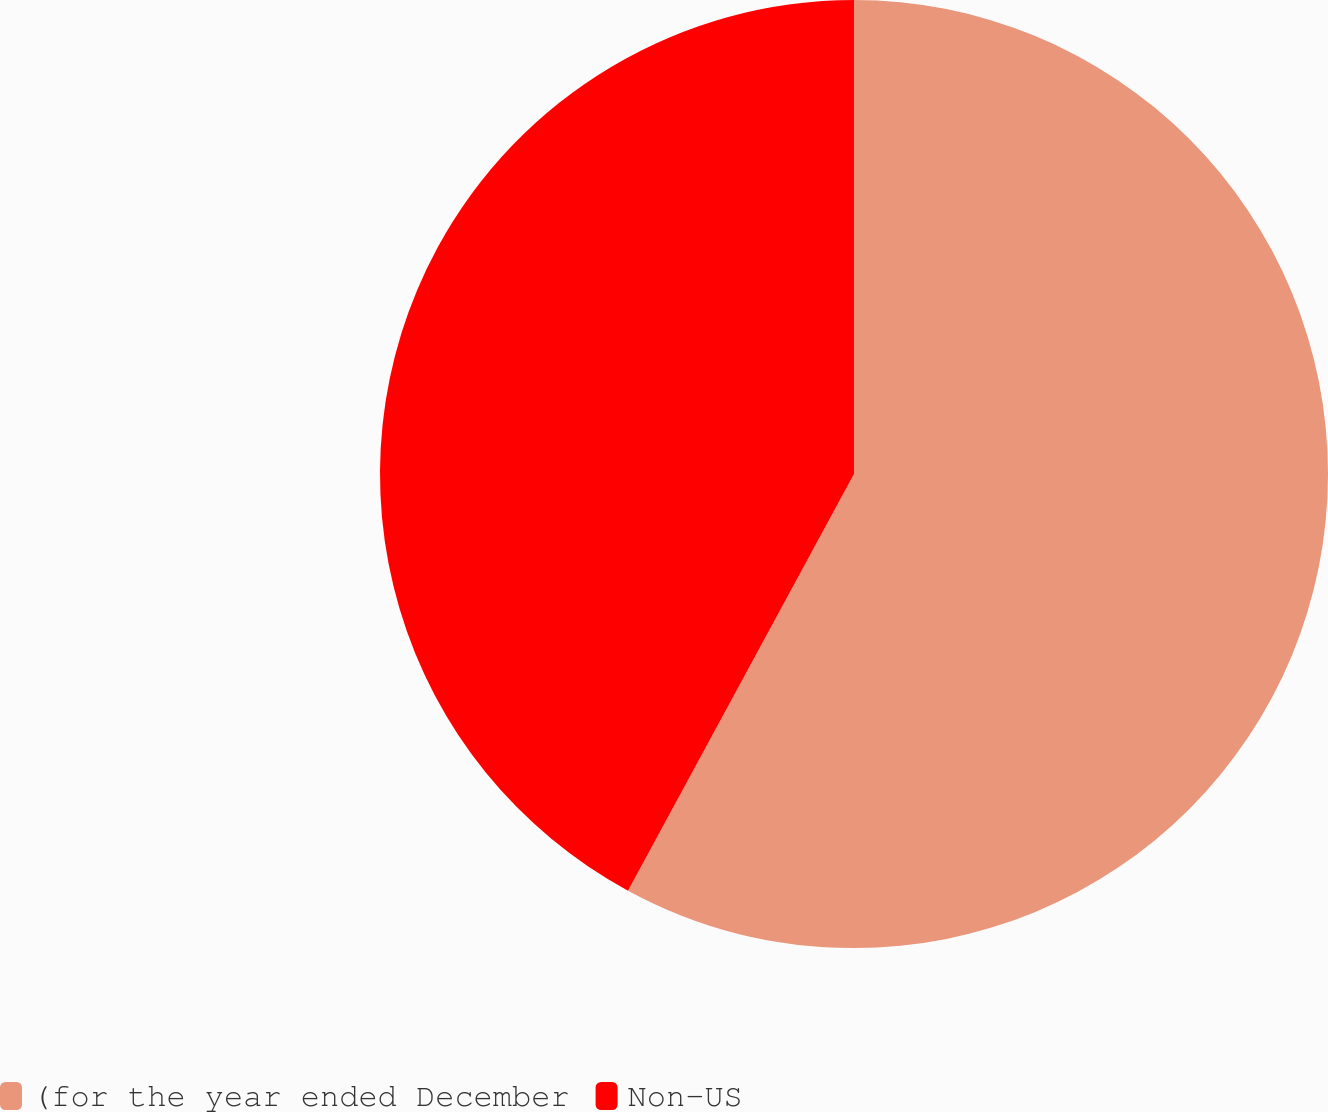Convert chart. <chart><loc_0><loc_0><loc_500><loc_500><pie_chart><fcel>(for the year ended December<fcel>Non-US<nl><fcel>57.91%<fcel>42.09%<nl></chart> 